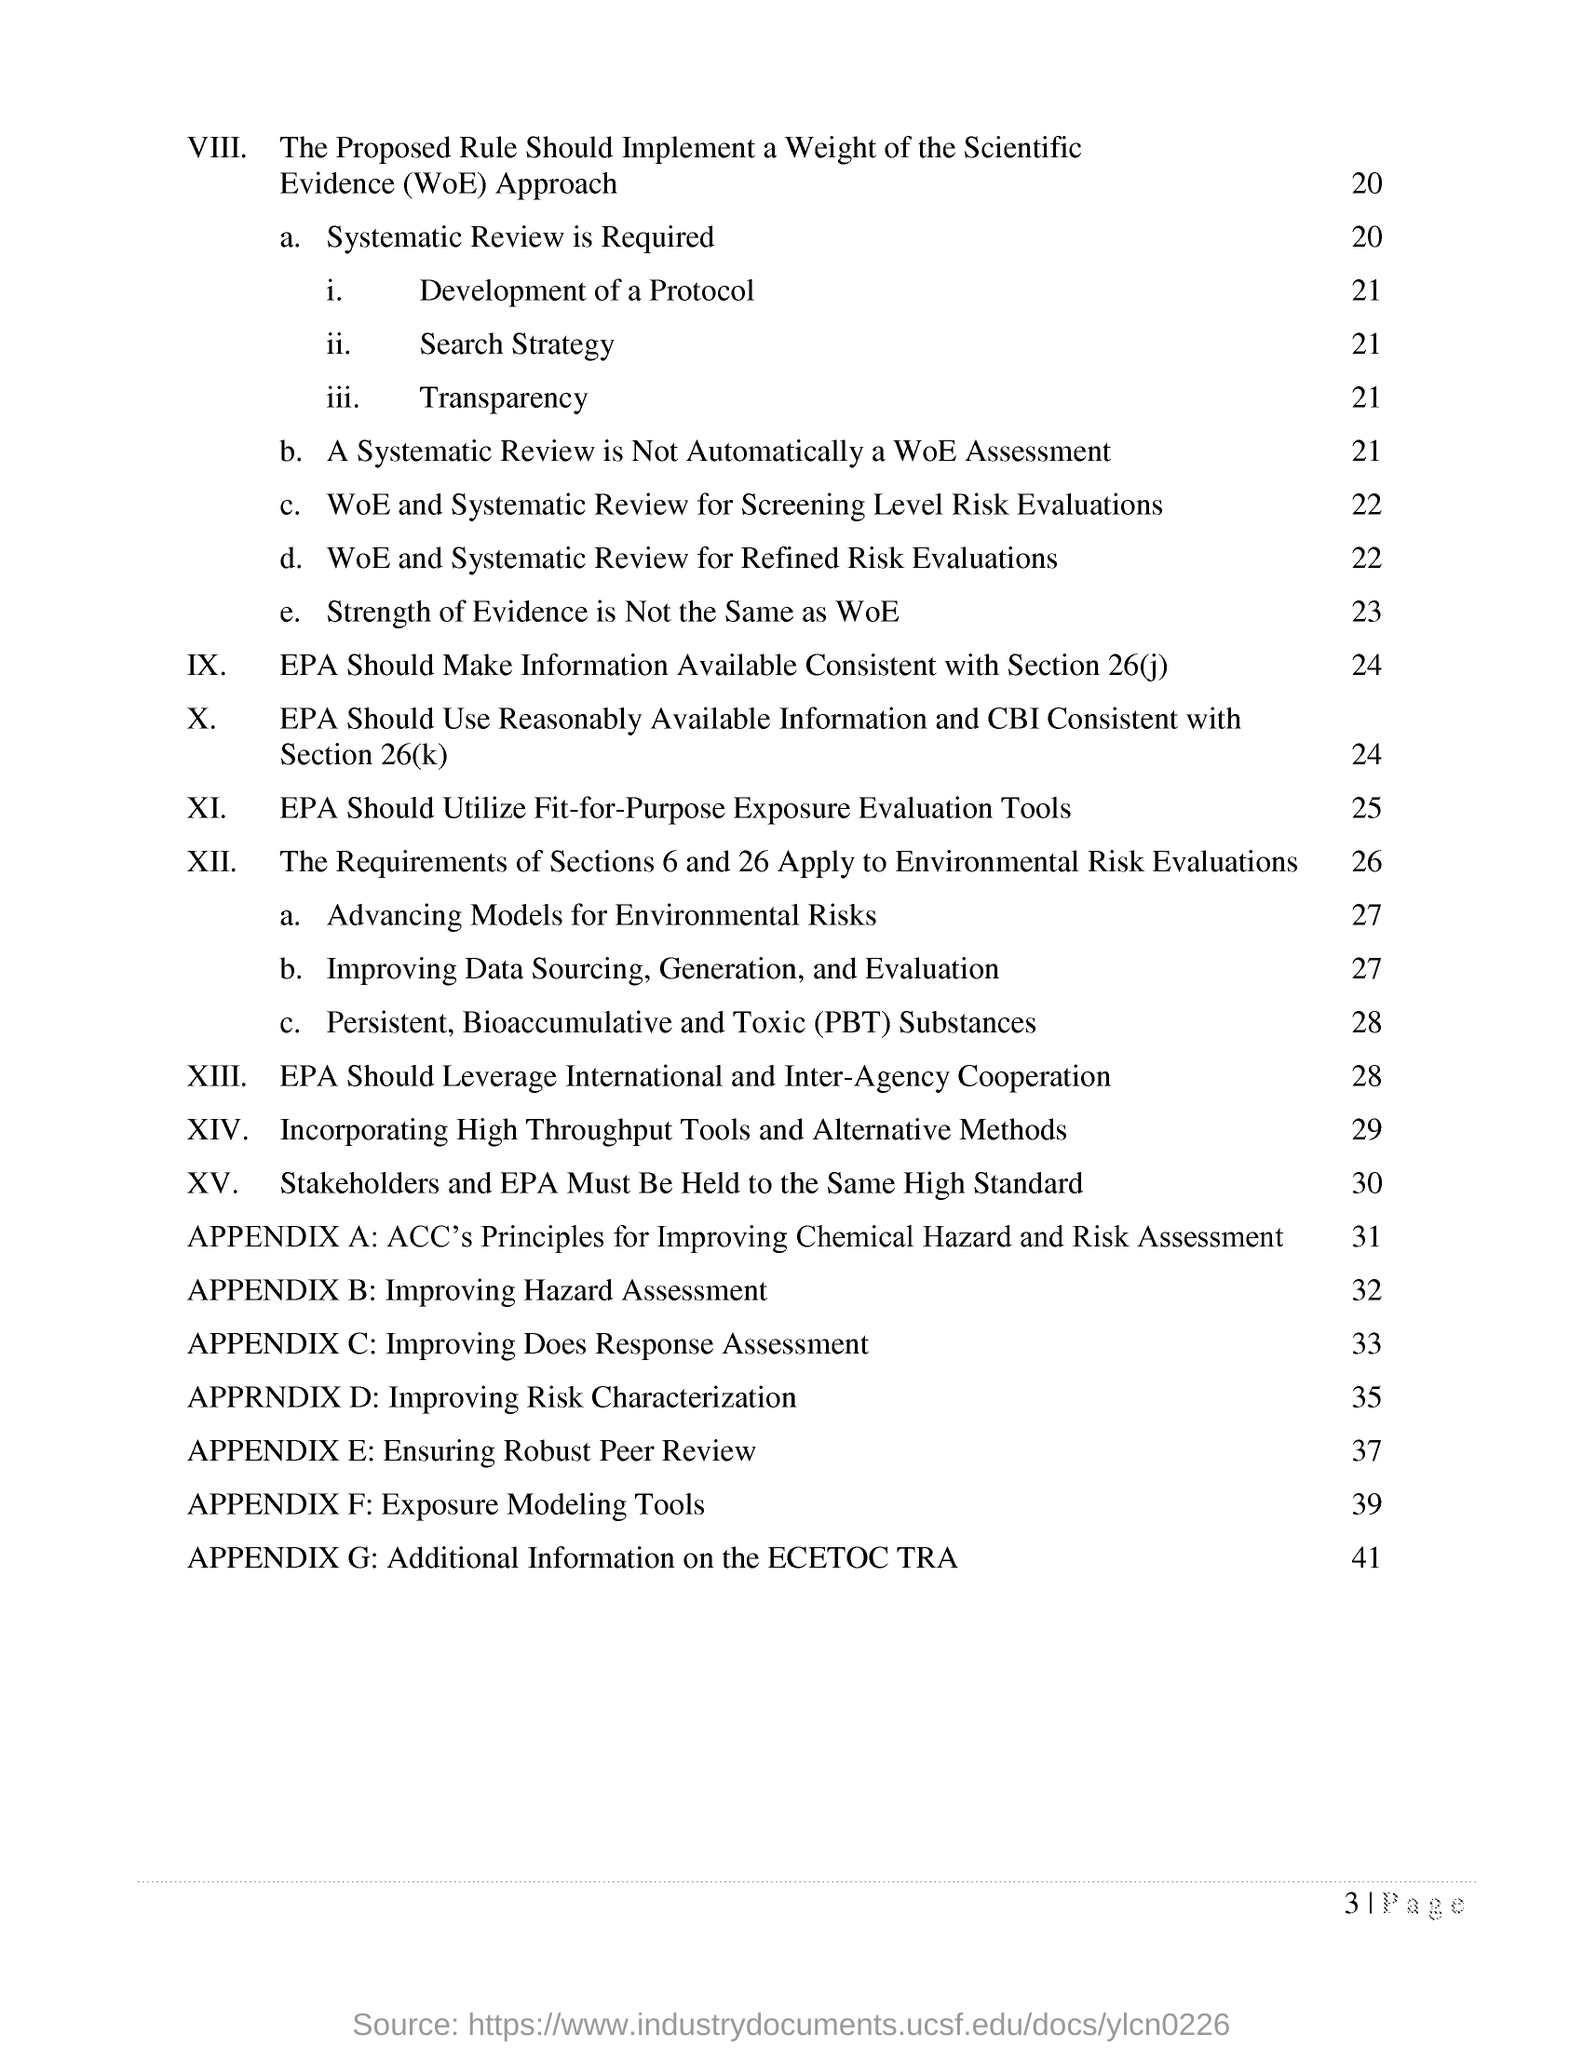Indicate a few pertinent items in this graphic. The page number of the section "incorporating high throughput tools and alternative methods" is 29. The title of Appendix B is "Improving Hazard Assessment. 